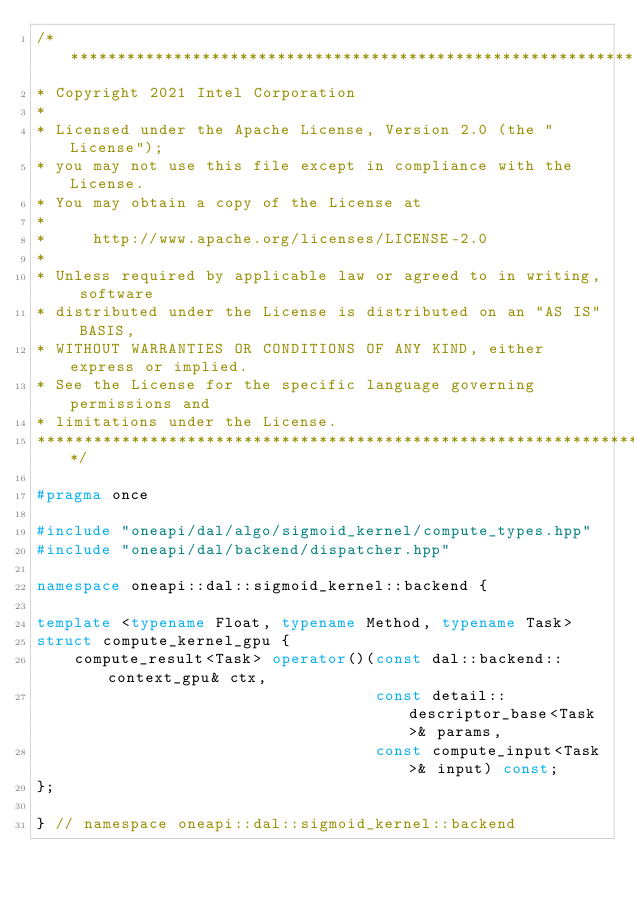<code> <loc_0><loc_0><loc_500><loc_500><_C++_>/*******************************************************************************
* Copyright 2021 Intel Corporation
*
* Licensed under the Apache License, Version 2.0 (the "License");
* you may not use this file except in compliance with the License.
* You may obtain a copy of the License at
*
*     http://www.apache.org/licenses/LICENSE-2.0
*
* Unless required by applicable law or agreed to in writing, software
* distributed under the License is distributed on an "AS IS" BASIS,
* WITHOUT WARRANTIES OR CONDITIONS OF ANY KIND, either express or implied.
* See the License for the specific language governing permissions and
* limitations under the License.
*******************************************************************************/

#pragma once

#include "oneapi/dal/algo/sigmoid_kernel/compute_types.hpp"
#include "oneapi/dal/backend/dispatcher.hpp"

namespace oneapi::dal::sigmoid_kernel::backend {

template <typename Float, typename Method, typename Task>
struct compute_kernel_gpu {
    compute_result<Task> operator()(const dal::backend::context_gpu& ctx,
                                    const detail::descriptor_base<Task>& params,
                                    const compute_input<Task>& input) const;
};

} // namespace oneapi::dal::sigmoid_kernel::backend
</code> 